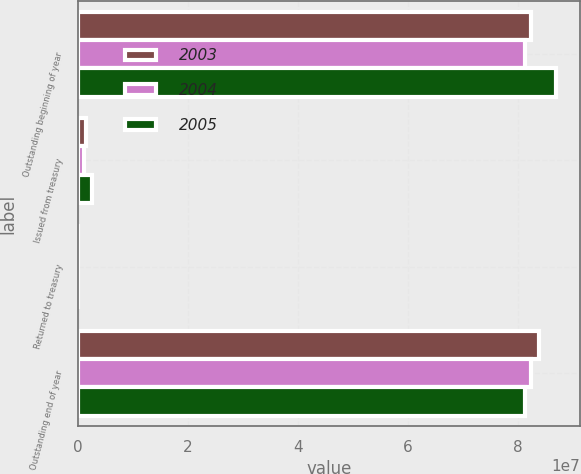<chart> <loc_0><loc_0><loc_500><loc_500><stacked_bar_chart><ecel><fcel>Outstanding beginning of year<fcel>Issued from treasury<fcel>Returned to treasury<fcel>Outstanding end of year<nl><fcel>2003<fcel>8.24071e+07<fcel>1.38818e+06<fcel>4113<fcel>8.37911e+07<nl><fcel>2004<fcel>8.12768e+07<fcel>1.15158e+06<fcel>21334<fcel>8.24071e+07<nl><fcel>2005<fcel>8.68351e+07<fcel>2.46555e+06<fcel>3077<fcel>8.12768e+07<nl></chart> 